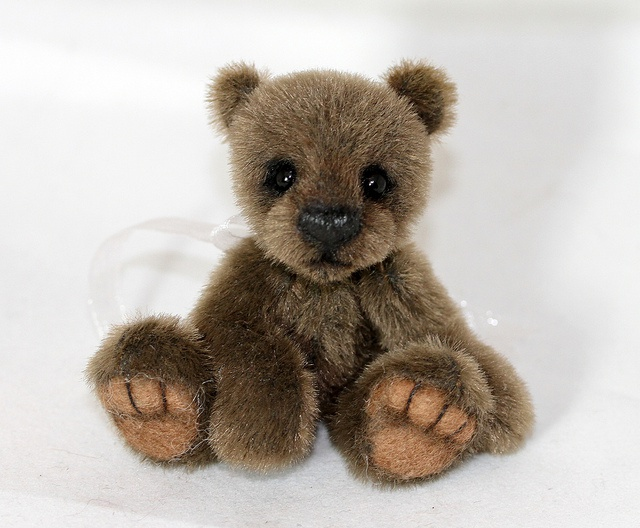Describe the objects in this image and their specific colors. I can see a teddy bear in white, black, maroon, and gray tones in this image. 